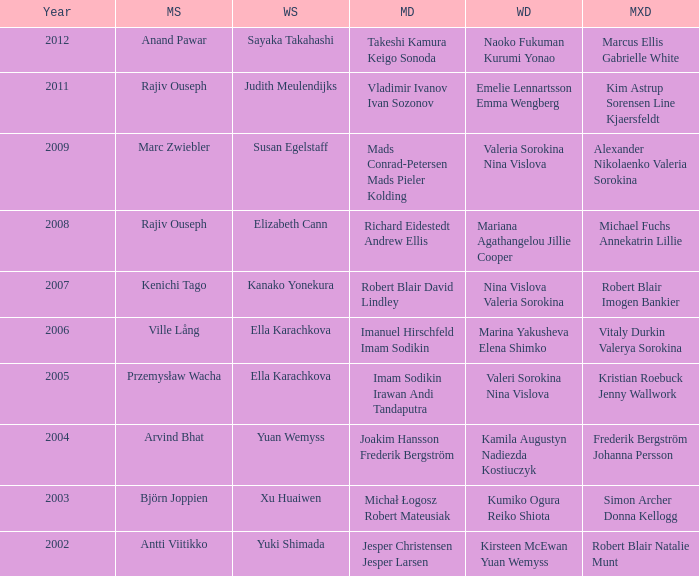What is the womens singles of marcus ellis gabrielle white? Sayaka Takahashi. 